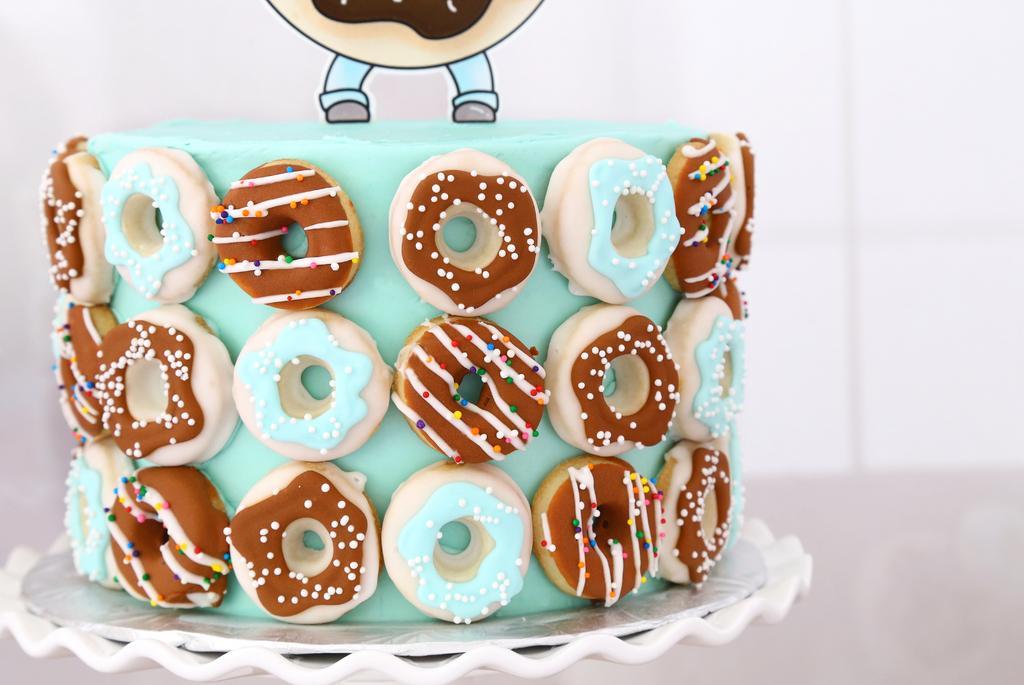How would you summarize this image in a sentence or two? In this image I can see the cake which is colorful. It is on the white color object. And there is a white background. 